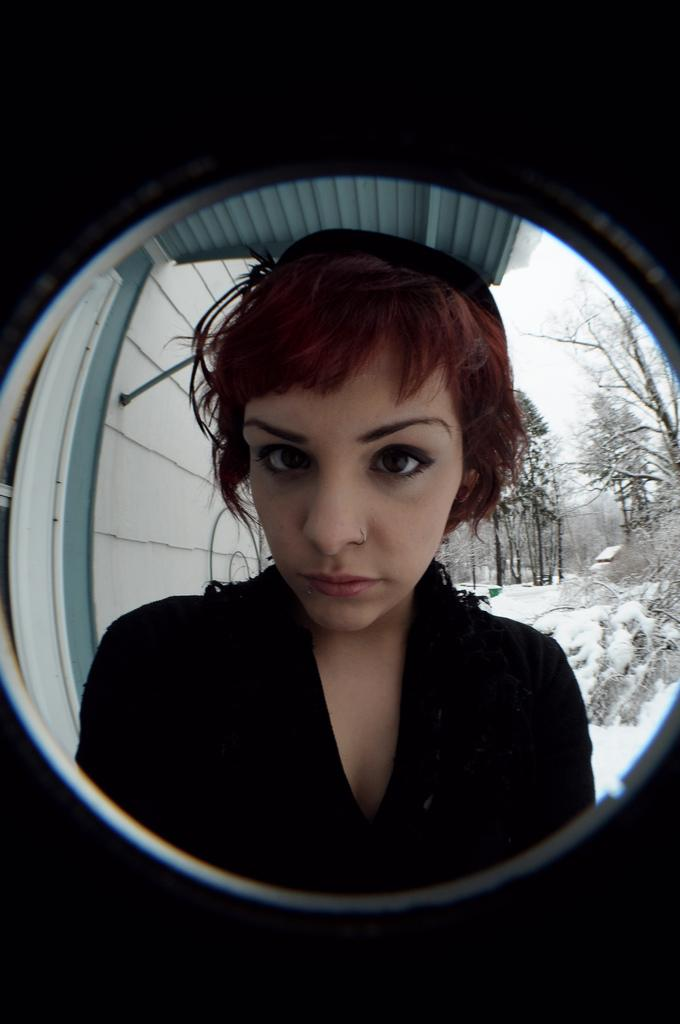What is the main object in the image? There is a door lens in the image. What can be seen through the door lens? A person is visible through the door lens. What is the background of the image like? There is snow, trees, and the sky visible in the background of the image. What type of badge is the person wearing on the floor in the image? There is no person wearing a badge on the floor in the image. What appliance can be seen in the image? There is no appliance present in the image. 